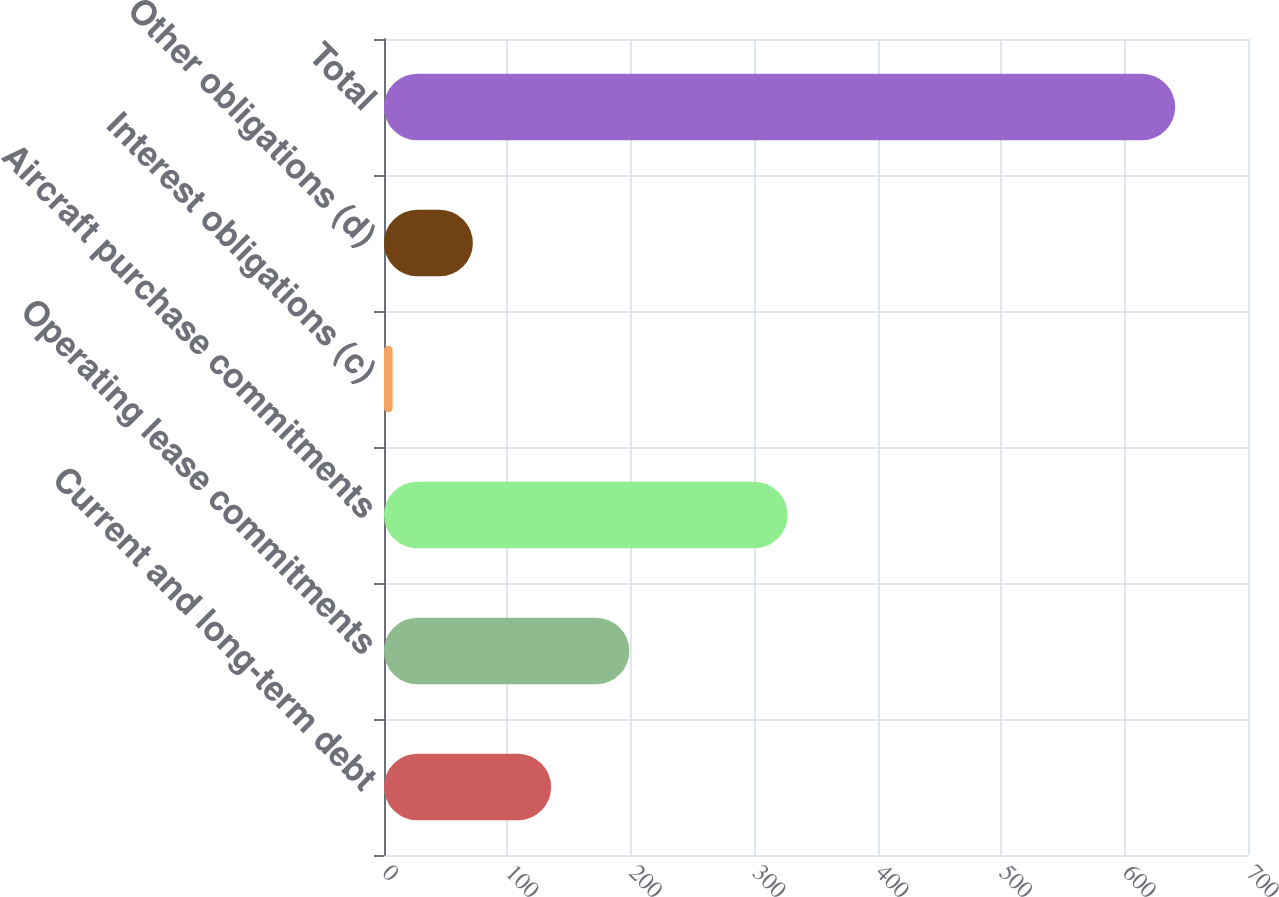Convert chart to OTSL. <chart><loc_0><loc_0><loc_500><loc_500><bar_chart><fcel>Current and long-term debt<fcel>Operating lease commitments<fcel>Aircraft purchase commitments<fcel>Interest obligations (c)<fcel>Other obligations (d)<fcel>Total<nl><fcel>135.4<fcel>198.8<fcel>327<fcel>7<fcel>72<fcel>641<nl></chart> 